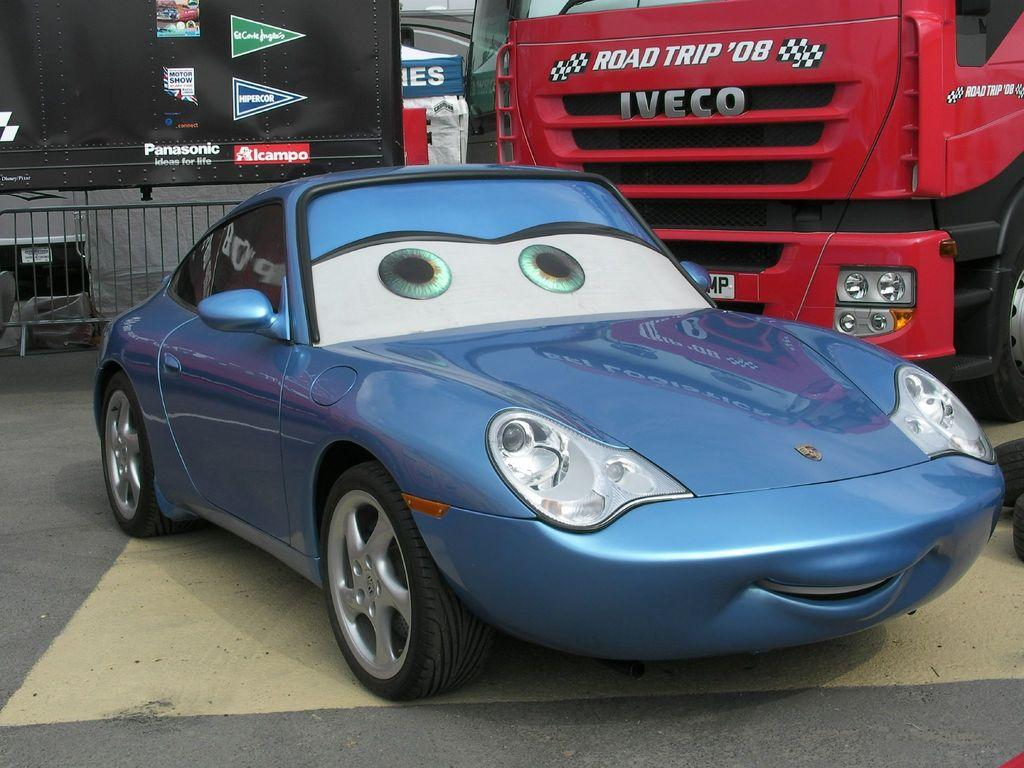What types of vehicles are in the image? There are vehicles in the image, but the specific types are not mentioned in the facts. What can be seen on the left side of the image? There is railing on the left side of the image. What is visible in the background of the image? There is a board visible in the background of the image, and there are also objects present. What type of feast is being prepared in the image? There is no mention of a feast or any food preparation in the image. Can you tell me how many faucets are visible in the image? There is no mention of a faucet or any plumbing fixtures in the image. 